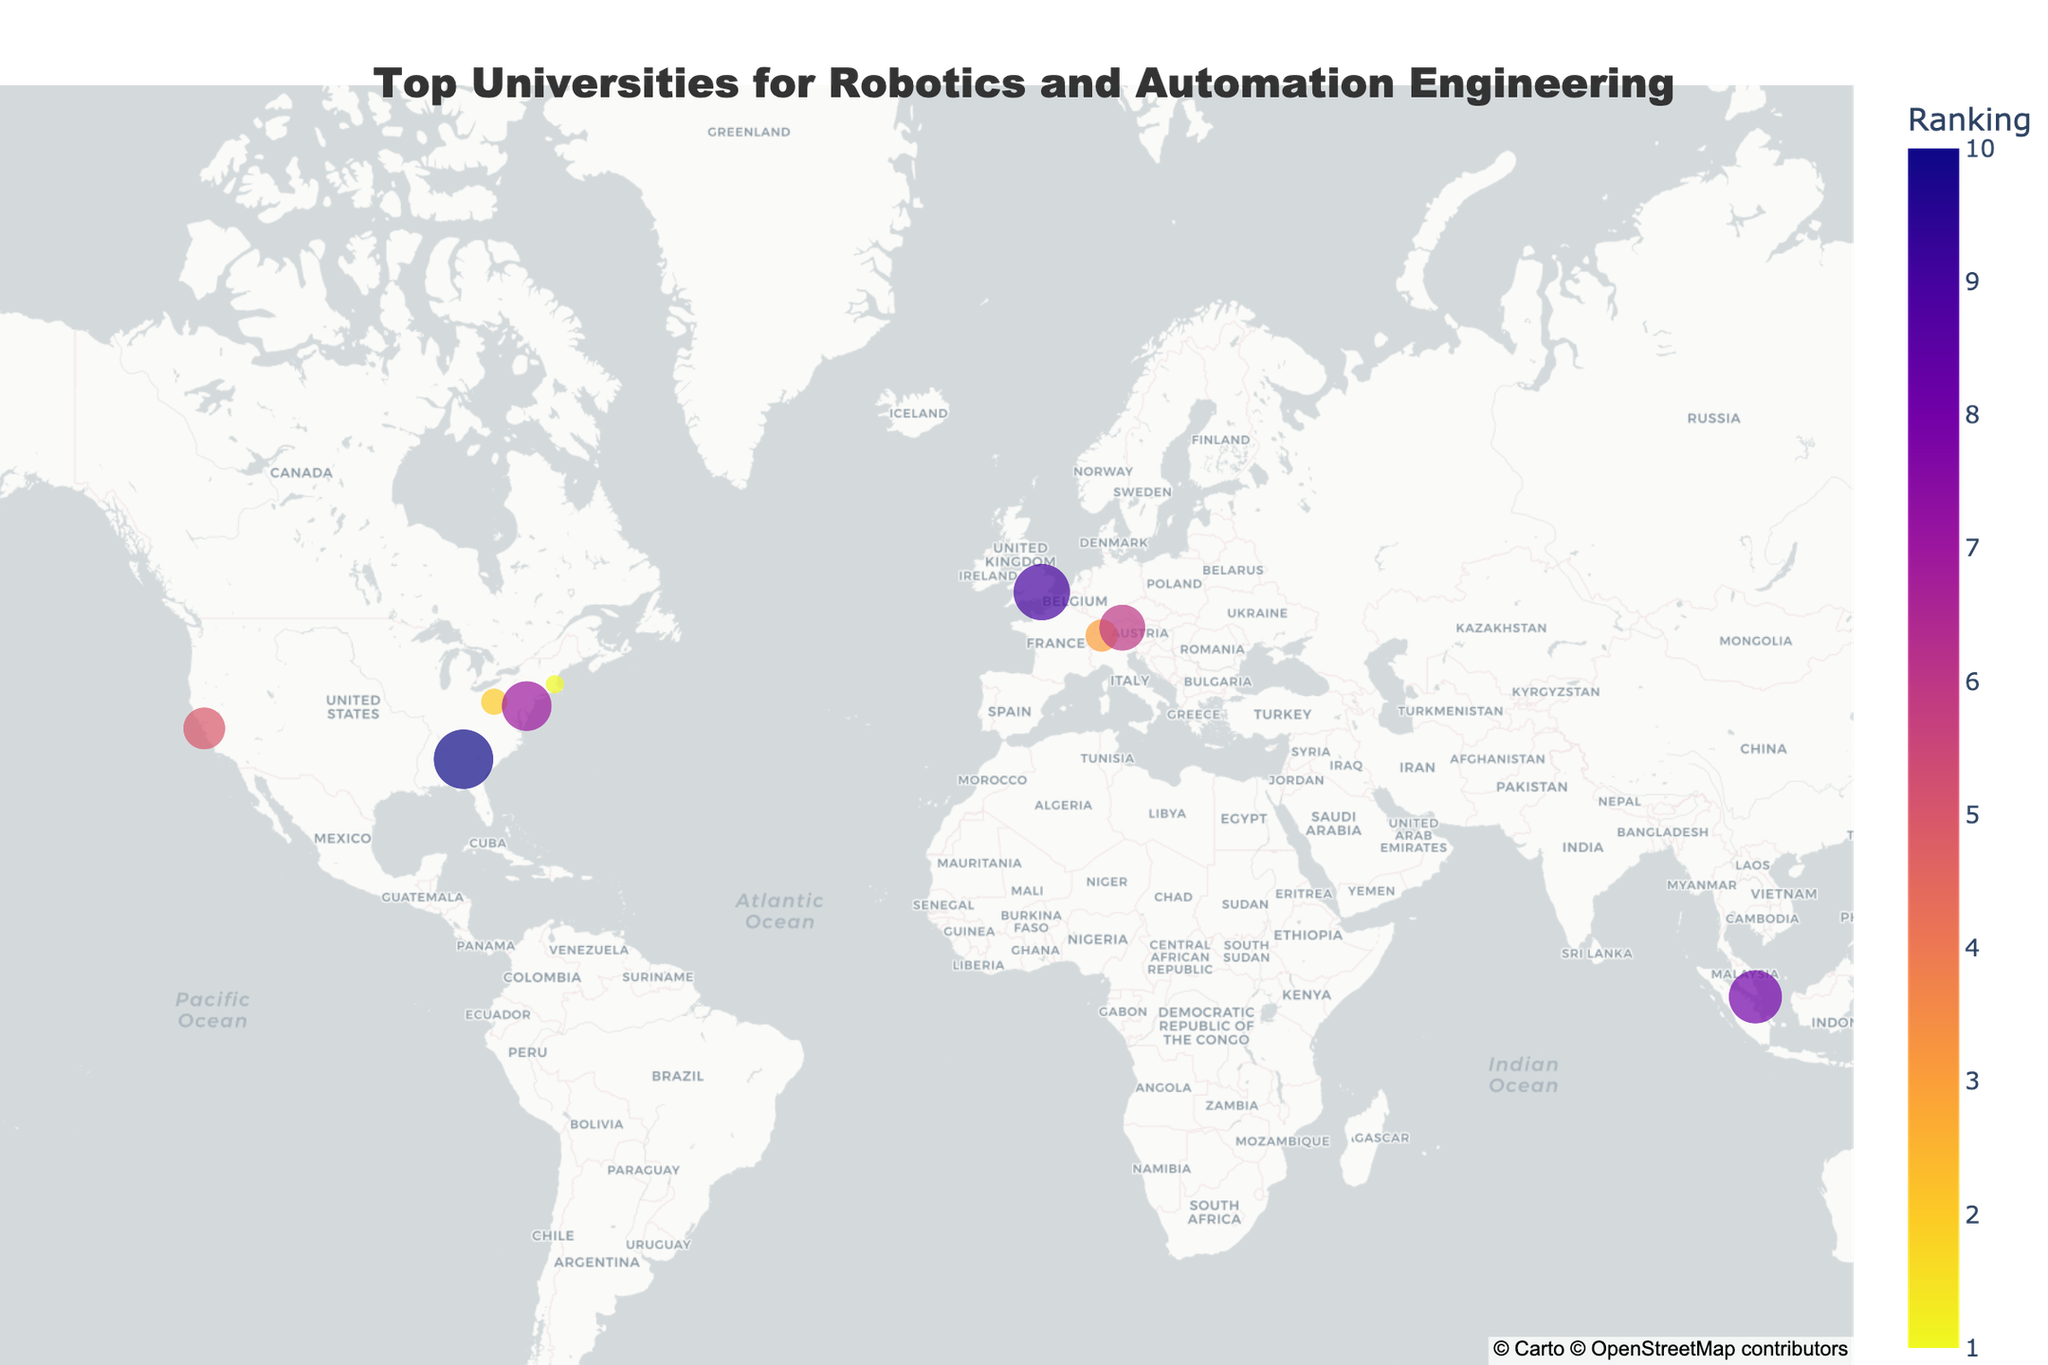Where is the top-ranked university located? The top-ranked university is the Massachusetts Institute of Technology, which is located in the USA. Looking at the map, it is located at approximately latitude 42.3601 and longitude -71.0942.
Answer: USA Which country has the most universities in the top 10 list? The USA has the most universities in the top 10 list, with a total of 5 universities: Massachusetts Institute of Technology, Carnegie Mellon University, Stanford University, University of Pennsylvania, and Georgia Institute of Technology.
Answer: USA What is the ranking of ETH Zurich, and what notable program does it offer? ETH Zurich is ranked 3rd. The notable program it offers is the Autonomous Systems Lab.
Answer: 3, Autonomous Systems Lab How many universities in the top 10 list are from Europe? There are 3 universities in the top 10 list from Europe: ETH Zurich (Switzerland), Technical University of Munich (Germany), and Imperial College London (UK).
Answer: 3 Which university has the highest rank among Asian universities, and what is its notable program? The University of Tokyo has the highest rank among Asian universities, which is ranked 4th. Its notable program is Intelligent Systems and Informatics.
Answer: University of Tokyo, Intelligent Systems and Informatics Compare the ranks of Technical University of Munich and University of Pennsylvania. Which one is higher? The University of Pennsylvania is ranked higher compared to the Technical University of Munich. University of Pennsylvania is ranked 7th, while Technical University of Munich is ranked 6th.
Answer: Technical University of Munich Which university in the top 10 list is situated closest to the equator? The National University of Singapore is situated closest to the equator, located at latitude 1.2966 and longitude 103.7764.
Answer: National University of Singapore How many universities from the USA are ranked within the top 5? There are 3 universities from the USA ranked within the top 5: Massachusetts Institute of Technology (1st), Carnegie Mellon University (2nd), and Stanford University (5th).
Answer: 3 What is the latitude and longitude of the University of Tokyo? The University of Tokyo is located at latitude 35.7128 and longitude 139.7624.
Answer: 35.7128, 139.7624 